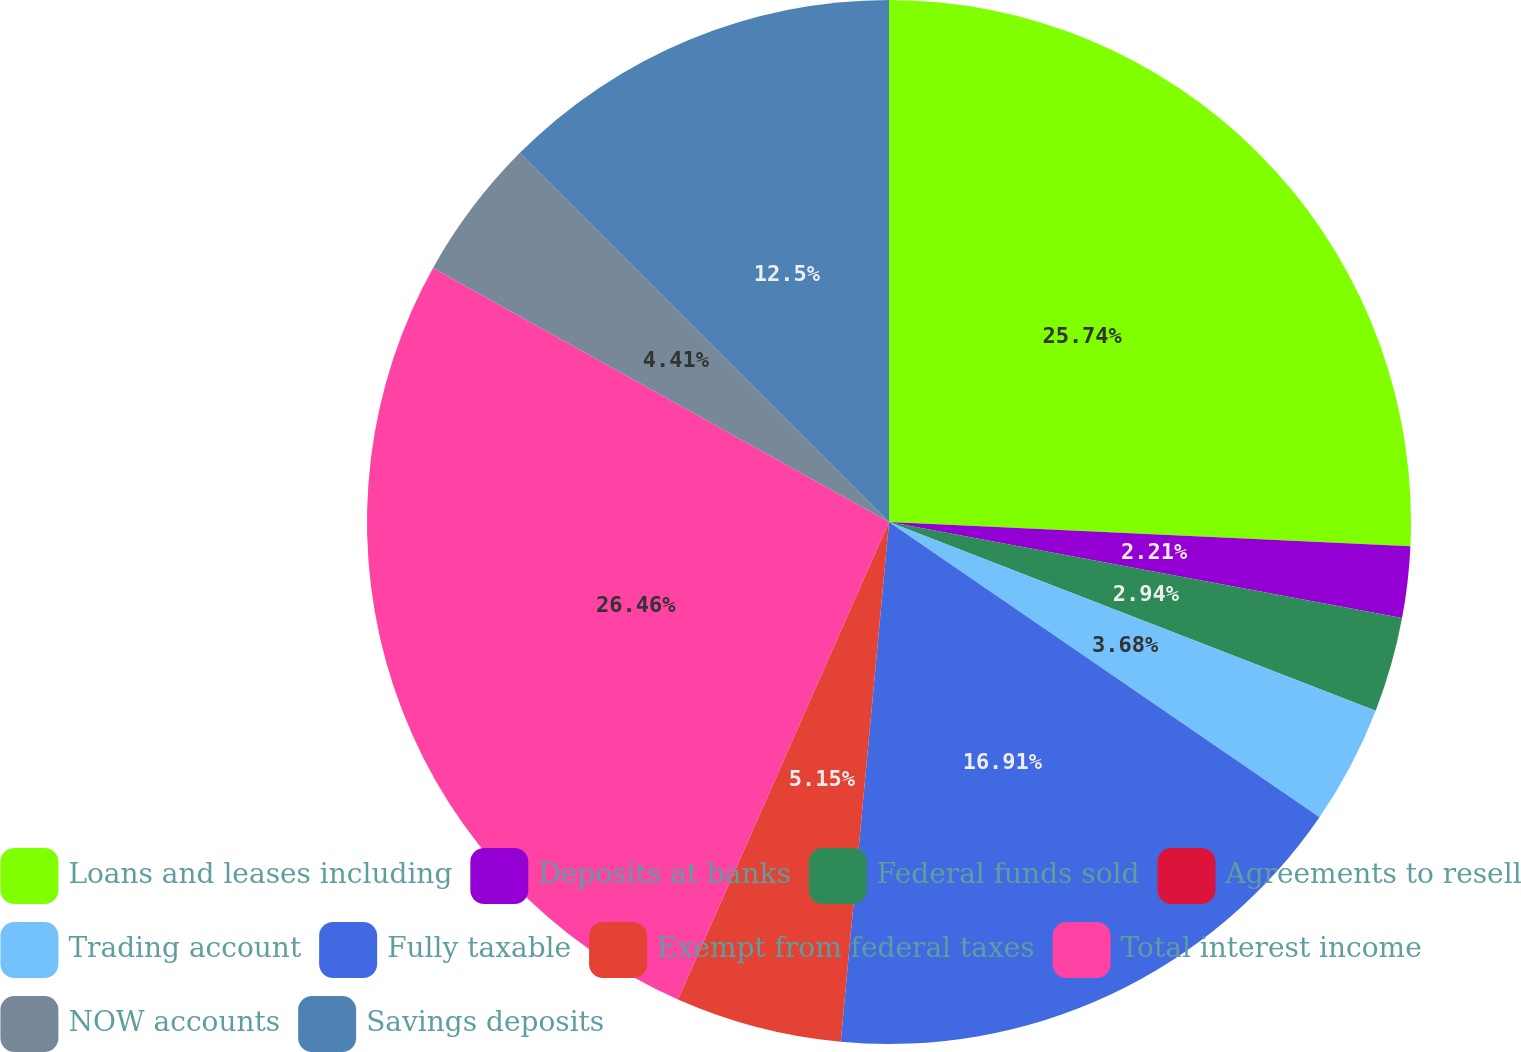<chart> <loc_0><loc_0><loc_500><loc_500><pie_chart><fcel>Loans and leases including<fcel>Deposits at banks<fcel>Federal funds sold<fcel>Agreements to resell<fcel>Trading account<fcel>Fully taxable<fcel>Exempt from federal taxes<fcel>Total interest income<fcel>NOW accounts<fcel>Savings deposits<nl><fcel>25.74%<fcel>2.21%<fcel>2.94%<fcel>0.0%<fcel>3.68%<fcel>16.91%<fcel>5.15%<fcel>26.47%<fcel>4.41%<fcel>12.5%<nl></chart> 